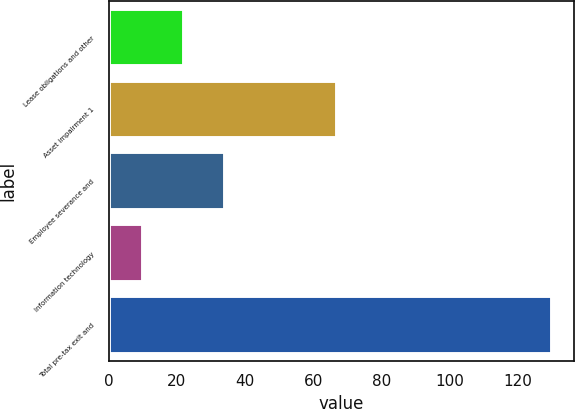Convert chart to OTSL. <chart><loc_0><loc_0><loc_500><loc_500><bar_chart><fcel>Lease obligations and other<fcel>Asset impairment 1<fcel>Employee severance and<fcel>Information technology<fcel>Total pre-tax exit and<nl><fcel>22<fcel>67<fcel>34<fcel>10<fcel>130<nl></chart> 